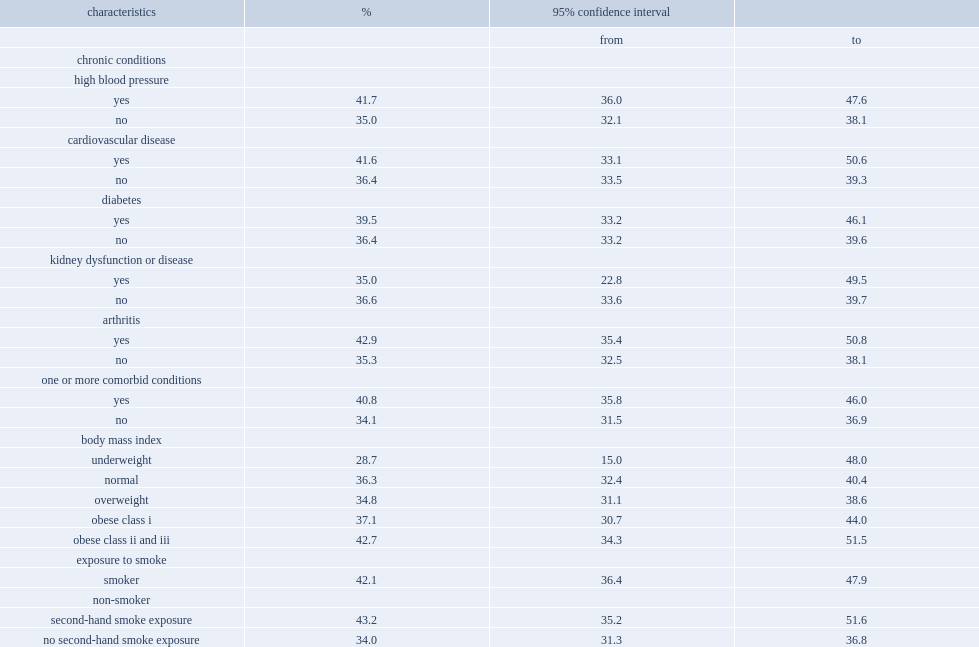Among people with high blood pressure or currently taking medication to control their blood pressure, what was the percentage of having experienced tinnitus from 2012 to 2015 in canada? 41.7. Among people people without high blood pressure, what was the percentage of having experienced tinnitus from 2012 to 2015 in canada? 35.0. What was the percentage of individuals with arthritis having experienced tinnitus from 2012 to 2015 in canada? 42.9. What was the percentage of individuals without arthritis having experienced tinnitus from 2012 to 2015 in canada? 35.3. Which group had a higher prevalence of tinnitus from 2012 to 2015 in canada, people who reported one or more comorbid chronic conditions or those without any chronic conditions? Yes. What was the percentage of people who reported one or more comorbid chronic conditions having experienced tinnitus from 2012 to 2015 in canada? 40.8. What was the percentage of people without any chronic conditions having experienced tinnitus from 2012 to 2015 in canada? 34.1. Which group were more likely to report tinnitus from 2012 to 2015 in canada, people exposed to smoke-directly as a smoker or indirectly through second-hand smoke or non-smokers who were not exposed to second-hand smoke? Smoker. What was the percentage of people exposed to smoke directly as a smoker having experienced tinnitus from 2012 to 2015 in canada? 42.1. What was the percentage of people exposed to smoke indirectly through second-hand smoke having experienced tinnitus from 2012 to 2015 in canada? 43.2. What was the percentage of non-smokers who were not exposed to second-hand smoke having experienced tinnitus from 2012 to 2015 in canada? 34.0. 